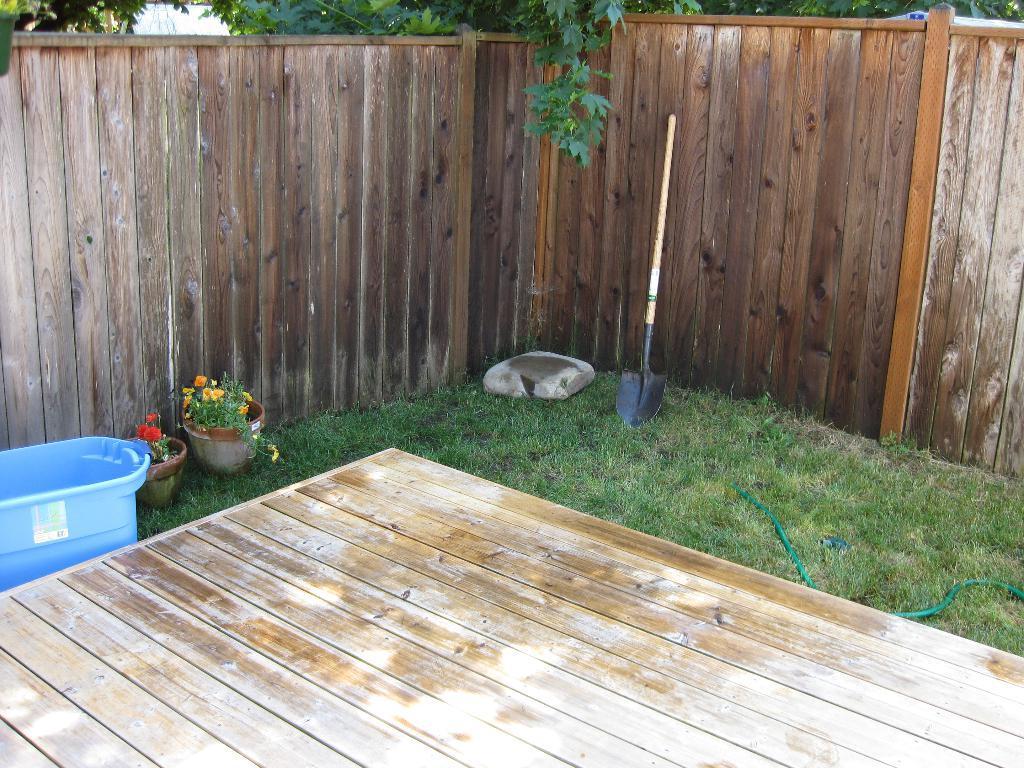Describe this image in one or two sentences. In this picture we can see backyard of the house with wooden fence. To the left side of the image one plastic tub and two pots are there. The land is full of grass. Bottom of the image wooden floor is present. Behind the fence trees are there. 